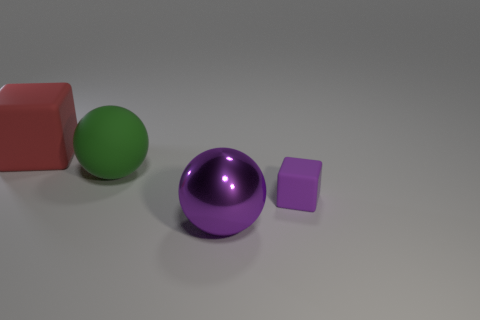There is a purple thing that is the same shape as the red thing; what is its size?
Offer a very short reply. Small. Are there any small things of the same color as the shiny sphere?
Keep it short and to the point. Yes. There is another object that is the same color as the tiny matte object; what is it made of?
Your answer should be very brief. Metal. How many metallic spheres have the same color as the large shiny object?
Provide a short and direct response. 0. How many objects are rubber blocks that are right of the red matte object or tiny yellow metallic spheres?
Provide a succinct answer. 1. What color is the large ball that is the same material as the large red thing?
Make the answer very short. Green. Is there a green sphere that has the same size as the purple block?
Provide a succinct answer. No. What number of things are either objects that are on the left side of the big purple ball or purple things in front of the purple cube?
Offer a very short reply. 3. There is a red rubber object that is the same size as the green matte thing; what is its shape?
Your response must be concise. Cube. Are there any tiny yellow objects that have the same shape as the red thing?
Your answer should be compact. No. 